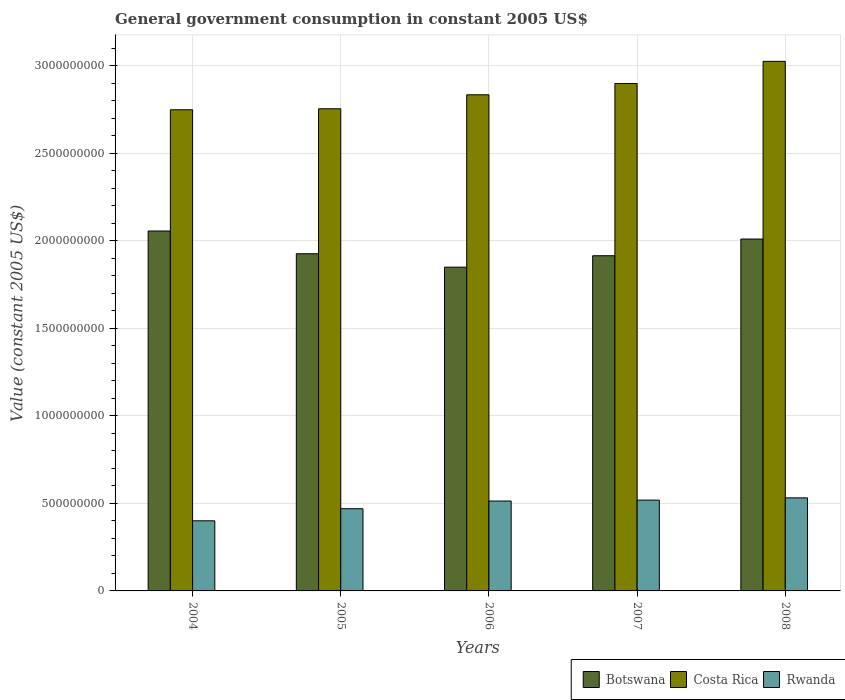How many different coloured bars are there?
Offer a very short reply. 3. Are the number of bars on each tick of the X-axis equal?
Ensure brevity in your answer.  Yes. How many bars are there on the 1st tick from the right?
Give a very brief answer. 3. What is the label of the 1st group of bars from the left?
Your response must be concise. 2004. What is the government conusmption in Costa Rica in 2006?
Your answer should be very brief. 2.84e+09. Across all years, what is the maximum government conusmption in Botswana?
Keep it short and to the point. 2.06e+09. Across all years, what is the minimum government conusmption in Botswana?
Offer a very short reply. 1.85e+09. What is the total government conusmption in Botswana in the graph?
Ensure brevity in your answer.  9.76e+09. What is the difference between the government conusmption in Botswana in 2004 and that in 2008?
Offer a very short reply. 4.60e+07. What is the difference between the government conusmption in Rwanda in 2007 and the government conusmption in Botswana in 2006?
Provide a succinct answer. -1.33e+09. What is the average government conusmption in Costa Rica per year?
Ensure brevity in your answer.  2.85e+09. In the year 2007, what is the difference between the government conusmption in Botswana and government conusmption in Rwanda?
Your answer should be compact. 1.40e+09. What is the ratio of the government conusmption in Rwanda in 2005 to that in 2007?
Provide a short and direct response. 0.91. Is the government conusmption in Costa Rica in 2005 less than that in 2007?
Offer a very short reply. Yes. What is the difference between the highest and the second highest government conusmption in Costa Rica?
Make the answer very short. 1.27e+08. What is the difference between the highest and the lowest government conusmption in Botswana?
Provide a succinct answer. 2.07e+08. What does the 2nd bar from the left in 2005 represents?
Provide a succinct answer. Costa Rica. What does the 1st bar from the right in 2008 represents?
Ensure brevity in your answer.  Rwanda. Are all the bars in the graph horizontal?
Your response must be concise. No. How many years are there in the graph?
Provide a short and direct response. 5. What is the difference between two consecutive major ticks on the Y-axis?
Ensure brevity in your answer.  5.00e+08. Does the graph contain any zero values?
Offer a very short reply. No. How are the legend labels stacked?
Your answer should be compact. Horizontal. What is the title of the graph?
Ensure brevity in your answer.  General government consumption in constant 2005 US$. What is the label or title of the Y-axis?
Keep it short and to the point. Value (constant 2005 US$). What is the Value (constant 2005 US$) of Botswana in 2004?
Offer a very short reply. 2.06e+09. What is the Value (constant 2005 US$) in Costa Rica in 2004?
Provide a short and direct response. 2.75e+09. What is the Value (constant 2005 US$) of Rwanda in 2004?
Your response must be concise. 4.01e+08. What is the Value (constant 2005 US$) in Botswana in 2005?
Keep it short and to the point. 1.93e+09. What is the Value (constant 2005 US$) of Costa Rica in 2005?
Provide a succinct answer. 2.76e+09. What is the Value (constant 2005 US$) of Rwanda in 2005?
Ensure brevity in your answer.  4.70e+08. What is the Value (constant 2005 US$) in Botswana in 2006?
Give a very brief answer. 1.85e+09. What is the Value (constant 2005 US$) of Costa Rica in 2006?
Offer a terse response. 2.84e+09. What is the Value (constant 2005 US$) of Rwanda in 2006?
Your answer should be very brief. 5.14e+08. What is the Value (constant 2005 US$) in Botswana in 2007?
Your response must be concise. 1.92e+09. What is the Value (constant 2005 US$) of Costa Rica in 2007?
Give a very brief answer. 2.90e+09. What is the Value (constant 2005 US$) of Rwanda in 2007?
Offer a terse response. 5.19e+08. What is the Value (constant 2005 US$) in Botswana in 2008?
Give a very brief answer. 2.01e+09. What is the Value (constant 2005 US$) of Costa Rica in 2008?
Your answer should be very brief. 3.03e+09. What is the Value (constant 2005 US$) in Rwanda in 2008?
Your answer should be compact. 5.32e+08. Across all years, what is the maximum Value (constant 2005 US$) in Botswana?
Your answer should be very brief. 2.06e+09. Across all years, what is the maximum Value (constant 2005 US$) of Costa Rica?
Give a very brief answer. 3.03e+09. Across all years, what is the maximum Value (constant 2005 US$) of Rwanda?
Provide a short and direct response. 5.32e+08. Across all years, what is the minimum Value (constant 2005 US$) in Botswana?
Offer a terse response. 1.85e+09. Across all years, what is the minimum Value (constant 2005 US$) of Costa Rica?
Offer a very short reply. 2.75e+09. Across all years, what is the minimum Value (constant 2005 US$) in Rwanda?
Make the answer very short. 4.01e+08. What is the total Value (constant 2005 US$) of Botswana in the graph?
Your answer should be very brief. 9.76e+09. What is the total Value (constant 2005 US$) of Costa Rica in the graph?
Your answer should be very brief. 1.43e+1. What is the total Value (constant 2005 US$) of Rwanda in the graph?
Make the answer very short. 2.43e+09. What is the difference between the Value (constant 2005 US$) in Botswana in 2004 and that in 2005?
Provide a succinct answer. 1.30e+08. What is the difference between the Value (constant 2005 US$) in Costa Rica in 2004 and that in 2005?
Provide a succinct answer. -5.66e+06. What is the difference between the Value (constant 2005 US$) of Rwanda in 2004 and that in 2005?
Give a very brief answer. -6.90e+07. What is the difference between the Value (constant 2005 US$) of Botswana in 2004 and that in 2006?
Your answer should be very brief. 2.07e+08. What is the difference between the Value (constant 2005 US$) in Costa Rica in 2004 and that in 2006?
Keep it short and to the point. -8.56e+07. What is the difference between the Value (constant 2005 US$) of Rwanda in 2004 and that in 2006?
Your answer should be compact. -1.13e+08. What is the difference between the Value (constant 2005 US$) of Botswana in 2004 and that in 2007?
Keep it short and to the point. 1.41e+08. What is the difference between the Value (constant 2005 US$) of Costa Rica in 2004 and that in 2007?
Keep it short and to the point. -1.50e+08. What is the difference between the Value (constant 2005 US$) of Rwanda in 2004 and that in 2007?
Give a very brief answer. -1.18e+08. What is the difference between the Value (constant 2005 US$) of Botswana in 2004 and that in 2008?
Make the answer very short. 4.60e+07. What is the difference between the Value (constant 2005 US$) of Costa Rica in 2004 and that in 2008?
Make the answer very short. -2.77e+08. What is the difference between the Value (constant 2005 US$) in Rwanda in 2004 and that in 2008?
Offer a very short reply. -1.31e+08. What is the difference between the Value (constant 2005 US$) of Botswana in 2005 and that in 2006?
Provide a short and direct response. 7.66e+07. What is the difference between the Value (constant 2005 US$) in Costa Rica in 2005 and that in 2006?
Keep it short and to the point. -7.99e+07. What is the difference between the Value (constant 2005 US$) in Rwanda in 2005 and that in 2006?
Offer a very short reply. -4.40e+07. What is the difference between the Value (constant 2005 US$) in Botswana in 2005 and that in 2007?
Your response must be concise. 1.14e+07. What is the difference between the Value (constant 2005 US$) in Costa Rica in 2005 and that in 2007?
Provide a succinct answer. -1.44e+08. What is the difference between the Value (constant 2005 US$) in Rwanda in 2005 and that in 2007?
Offer a very short reply. -4.92e+07. What is the difference between the Value (constant 2005 US$) in Botswana in 2005 and that in 2008?
Offer a very short reply. -8.41e+07. What is the difference between the Value (constant 2005 US$) in Costa Rica in 2005 and that in 2008?
Offer a very short reply. -2.71e+08. What is the difference between the Value (constant 2005 US$) in Rwanda in 2005 and that in 2008?
Offer a terse response. -6.21e+07. What is the difference between the Value (constant 2005 US$) of Botswana in 2006 and that in 2007?
Offer a terse response. -6.51e+07. What is the difference between the Value (constant 2005 US$) of Costa Rica in 2006 and that in 2007?
Ensure brevity in your answer.  -6.44e+07. What is the difference between the Value (constant 2005 US$) of Rwanda in 2006 and that in 2007?
Make the answer very short. -5.18e+06. What is the difference between the Value (constant 2005 US$) of Botswana in 2006 and that in 2008?
Provide a short and direct response. -1.61e+08. What is the difference between the Value (constant 2005 US$) of Costa Rica in 2006 and that in 2008?
Your response must be concise. -1.91e+08. What is the difference between the Value (constant 2005 US$) of Rwanda in 2006 and that in 2008?
Provide a succinct answer. -1.81e+07. What is the difference between the Value (constant 2005 US$) in Botswana in 2007 and that in 2008?
Offer a very short reply. -9.55e+07. What is the difference between the Value (constant 2005 US$) in Costa Rica in 2007 and that in 2008?
Make the answer very short. -1.27e+08. What is the difference between the Value (constant 2005 US$) of Rwanda in 2007 and that in 2008?
Provide a succinct answer. -1.29e+07. What is the difference between the Value (constant 2005 US$) of Botswana in 2004 and the Value (constant 2005 US$) of Costa Rica in 2005?
Your answer should be compact. -6.98e+08. What is the difference between the Value (constant 2005 US$) of Botswana in 2004 and the Value (constant 2005 US$) of Rwanda in 2005?
Your answer should be very brief. 1.59e+09. What is the difference between the Value (constant 2005 US$) in Costa Rica in 2004 and the Value (constant 2005 US$) in Rwanda in 2005?
Provide a short and direct response. 2.28e+09. What is the difference between the Value (constant 2005 US$) of Botswana in 2004 and the Value (constant 2005 US$) of Costa Rica in 2006?
Keep it short and to the point. -7.78e+08. What is the difference between the Value (constant 2005 US$) of Botswana in 2004 and the Value (constant 2005 US$) of Rwanda in 2006?
Provide a succinct answer. 1.54e+09. What is the difference between the Value (constant 2005 US$) in Costa Rica in 2004 and the Value (constant 2005 US$) in Rwanda in 2006?
Keep it short and to the point. 2.24e+09. What is the difference between the Value (constant 2005 US$) in Botswana in 2004 and the Value (constant 2005 US$) in Costa Rica in 2007?
Keep it short and to the point. -8.43e+08. What is the difference between the Value (constant 2005 US$) in Botswana in 2004 and the Value (constant 2005 US$) in Rwanda in 2007?
Make the answer very short. 1.54e+09. What is the difference between the Value (constant 2005 US$) of Costa Rica in 2004 and the Value (constant 2005 US$) of Rwanda in 2007?
Provide a short and direct response. 2.23e+09. What is the difference between the Value (constant 2005 US$) of Botswana in 2004 and the Value (constant 2005 US$) of Costa Rica in 2008?
Make the answer very short. -9.69e+08. What is the difference between the Value (constant 2005 US$) of Botswana in 2004 and the Value (constant 2005 US$) of Rwanda in 2008?
Offer a terse response. 1.52e+09. What is the difference between the Value (constant 2005 US$) of Costa Rica in 2004 and the Value (constant 2005 US$) of Rwanda in 2008?
Offer a very short reply. 2.22e+09. What is the difference between the Value (constant 2005 US$) of Botswana in 2005 and the Value (constant 2005 US$) of Costa Rica in 2006?
Offer a very short reply. -9.08e+08. What is the difference between the Value (constant 2005 US$) in Botswana in 2005 and the Value (constant 2005 US$) in Rwanda in 2006?
Your response must be concise. 1.41e+09. What is the difference between the Value (constant 2005 US$) of Costa Rica in 2005 and the Value (constant 2005 US$) of Rwanda in 2006?
Your response must be concise. 2.24e+09. What is the difference between the Value (constant 2005 US$) of Botswana in 2005 and the Value (constant 2005 US$) of Costa Rica in 2007?
Offer a terse response. -9.73e+08. What is the difference between the Value (constant 2005 US$) in Botswana in 2005 and the Value (constant 2005 US$) in Rwanda in 2007?
Give a very brief answer. 1.41e+09. What is the difference between the Value (constant 2005 US$) of Costa Rica in 2005 and the Value (constant 2005 US$) of Rwanda in 2007?
Your response must be concise. 2.24e+09. What is the difference between the Value (constant 2005 US$) in Botswana in 2005 and the Value (constant 2005 US$) in Costa Rica in 2008?
Your answer should be compact. -1.10e+09. What is the difference between the Value (constant 2005 US$) in Botswana in 2005 and the Value (constant 2005 US$) in Rwanda in 2008?
Your answer should be very brief. 1.39e+09. What is the difference between the Value (constant 2005 US$) in Costa Rica in 2005 and the Value (constant 2005 US$) in Rwanda in 2008?
Your answer should be very brief. 2.22e+09. What is the difference between the Value (constant 2005 US$) in Botswana in 2006 and the Value (constant 2005 US$) in Costa Rica in 2007?
Offer a very short reply. -1.05e+09. What is the difference between the Value (constant 2005 US$) in Botswana in 2006 and the Value (constant 2005 US$) in Rwanda in 2007?
Provide a succinct answer. 1.33e+09. What is the difference between the Value (constant 2005 US$) in Costa Rica in 2006 and the Value (constant 2005 US$) in Rwanda in 2007?
Your response must be concise. 2.32e+09. What is the difference between the Value (constant 2005 US$) in Botswana in 2006 and the Value (constant 2005 US$) in Costa Rica in 2008?
Provide a short and direct response. -1.18e+09. What is the difference between the Value (constant 2005 US$) of Botswana in 2006 and the Value (constant 2005 US$) of Rwanda in 2008?
Ensure brevity in your answer.  1.32e+09. What is the difference between the Value (constant 2005 US$) of Costa Rica in 2006 and the Value (constant 2005 US$) of Rwanda in 2008?
Your answer should be very brief. 2.30e+09. What is the difference between the Value (constant 2005 US$) in Botswana in 2007 and the Value (constant 2005 US$) in Costa Rica in 2008?
Your answer should be compact. -1.11e+09. What is the difference between the Value (constant 2005 US$) of Botswana in 2007 and the Value (constant 2005 US$) of Rwanda in 2008?
Give a very brief answer. 1.38e+09. What is the difference between the Value (constant 2005 US$) in Costa Rica in 2007 and the Value (constant 2005 US$) in Rwanda in 2008?
Make the answer very short. 2.37e+09. What is the average Value (constant 2005 US$) in Botswana per year?
Offer a very short reply. 1.95e+09. What is the average Value (constant 2005 US$) in Costa Rica per year?
Offer a terse response. 2.85e+09. What is the average Value (constant 2005 US$) in Rwanda per year?
Provide a succinct answer. 4.87e+08. In the year 2004, what is the difference between the Value (constant 2005 US$) in Botswana and Value (constant 2005 US$) in Costa Rica?
Provide a succinct answer. -6.93e+08. In the year 2004, what is the difference between the Value (constant 2005 US$) in Botswana and Value (constant 2005 US$) in Rwanda?
Your answer should be compact. 1.66e+09. In the year 2004, what is the difference between the Value (constant 2005 US$) in Costa Rica and Value (constant 2005 US$) in Rwanda?
Keep it short and to the point. 2.35e+09. In the year 2005, what is the difference between the Value (constant 2005 US$) in Botswana and Value (constant 2005 US$) in Costa Rica?
Provide a succinct answer. -8.28e+08. In the year 2005, what is the difference between the Value (constant 2005 US$) of Botswana and Value (constant 2005 US$) of Rwanda?
Make the answer very short. 1.46e+09. In the year 2005, what is the difference between the Value (constant 2005 US$) of Costa Rica and Value (constant 2005 US$) of Rwanda?
Your answer should be very brief. 2.29e+09. In the year 2006, what is the difference between the Value (constant 2005 US$) of Botswana and Value (constant 2005 US$) of Costa Rica?
Give a very brief answer. -9.85e+08. In the year 2006, what is the difference between the Value (constant 2005 US$) of Botswana and Value (constant 2005 US$) of Rwanda?
Make the answer very short. 1.34e+09. In the year 2006, what is the difference between the Value (constant 2005 US$) in Costa Rica and Value (constant 2005 US$) in Rwanda?
Offer a very short reply. 2.32e+09. In the year 2007, what is the difference between the Value (constant 2005 US$) in Botswana and Value (constant 2005 US$) in Costa Rica?
Offer a terse response. -9.84e+08. In the year 2007, what is the difference between the Value (constant 2005 US$) of Botswana and Value (constant 2005 US$) of Rwanda?
Provide a succinct answer. 1.40e+09. In the year 2007, what is the difference between the Value (constant 2005 US$) in Costa Rica and Value (constant 2005 US$) in Rwanda?
Your answer should be compact. 2.38e+09. In the year 2008, what is the difference between the Value (constant 2005 US$) of Botswana and Value (constant 2005 US$) of Costa Rica?
Your answer should be compact. -1.02e+09. In the year 2008, what is the difference between the Value (constant 2005 US$) in Botswana and Value (constant 2005 US$) in Rwanda?
Keep it short and to the point. 1.48e+09. In the year 2008, what is the difference between the Value (constant 2005 US$) in Costa Rica and Value (constant 2005 US$) in Rwanda?
Provide a succinct answer. 2.49e+09. What is the ratio of the Value (constant 2005 US$) of Botswana in 2004 to that in 2005?
Provide a short and direct response. 1.07. What is the ratio of the Value (constant 2005 US$) of Costa Rica in 2004 to that in 2005?
Your answer should be compact. 1. What is the ratio of the Value (constant 2005 US$) of Rwanda in 2004 to that in 2005?
Keep it short and to the point. 0.85. What is the ratio of the Value (constant 2005 US$) in Botswana in 2004 to that in 2006?
Offer a very short reply. 1.11. What is the ratio of the Value (constant 2005 US$) in Costa Rica in 2004 to that in 2006?
Provide a short and direct response. 0.97. What is the ratio of the Value (constant 2005 US$) in Rwanda in 2004 to that in 2006?
Offer a terse response. 0.78. What is the ratio of the Value (constant 2005 US$) of Botswana in 2004 to that in 2007?
Provide a succinct answer. 1.07. What is the ratio of the Value (constant 2005 US$) of Costa Rica in 2004 to that in 2007?
Keep it short and to the point. 0.95. What is the ratio of the Value (constant 2005 US$) of Rwanda in 2004 to that in 2007?
Your response must be concise. 0.77. What is the ratio of the Value (constant 2005 US$) of Botswana in 2004 to that in 2008?
Provide a short and direct response. 1.02. What is the ratio of the Value (constant 2005 US$) of Costa Rica in 2004 to that in 2008?
Give a very brief answer. 0.91. What is the ratio of the Value (constant 2005 US$) of Rwanda in 2004 to that in 2008?
Provide a succinct answer. 0.75. What is the ratio of the Value (constant 2005 US$) in Botswana in 2005 to that in 2006?
Provide a short and direct response. 1.04. What is the ratio of the Value (constant 2005 US$) in Costa Rica in 2005 to that in 2006?
Offer a terse response. 0.97. What is the ratio of the Value (constant 2005 US$) in Rwanda in 2005 to that in 2006?
Offer a terse response. 0.91. What is the ratio of the Value (constant 2005 US$) of Costa Rica in 2005 to that in 2007?
Offer a terse response. 0.95. What is the ratio of the Value (constant 2005 US$) of Rwanda in 2005 to that in 2007?
Make the answer very short. 0.91. What is the ratio of the Value (constant 2005 US$) in Botswana in 2005 to that in 2008?
Make the answer very short. 0.96. What is the ratio of the Value (constant 2005 US$) of Costa Rica in 2005 to that in 2008?
Your answer should be compact. 0.91. What is the ratio of the Value (constant 2005 US$) of Rwanda in 2005 to that in 2008?
Ensure brevity in your answer.  0.88. What is the ratio of the Value (constant 2005 US$) of Costa Rica in 2006 to that in 2007?
Offer a very short reply. 0.98. What is the ratio of the Value (constant 2005 US$) of Rwanda in 2006 to that in 2007?
Your response must be concise. 0.99. What is the ratio of the Value (constant 2005 US$) in Botswana in 2006 to that in 2008?
Your answer should be very brief. 0.92. What is the ratio of the Value (constant 2005 US$) of Costa Rica in 2006 to that in 2008?
Your response must be concise. 0.94. What is the ratio of the Value (constant 2005 US$) in Rwanda in 2006 to that in 2008?
Make the answer very short. 0.97. What is the ratio of the Value (constant 2005 US$) in Botswana in 2007 to that in 2008?
Provide a succinct answer. 0.95. What is the ratio of the Value (constant 2005 US$) of Costa Rica in 2007 to that in 2008?
Provide a short and direct response. 0.96. What is the ratio of the Value (constant 2005 US$) of Rwanda in 2007 to that in 2008?
Ensure brevity in your answer.  0.98. What is the difference between the highest and the second highest Value (constant 2005 US$) of Botswana?
Provide a succinct answer. 4.60e+07. What is the difference between the highest and the second highest Value (constant 2005 US$) in Costa Rica?
Make the answer very short. 1.27e+08. What is the difference between the highest and the second highest Value (constant 2005 US$) in Rwanda?
Give a very brief answer. 1.29e+07. What is the difference between the highest and the lowest Value (constant 2005 US$) of Botswana?
Make the answer very short. 2.07e+08. What is the difference between the highest and the lowest Value (constant 2005 US$) of Costa Rica?
Ensure brevity in your answer.  2.77e+08. What is the difference between the highest and the lowest Value (constant 2005 US$) in Rwanda?
Your response must be concise. 1.31e+08. 